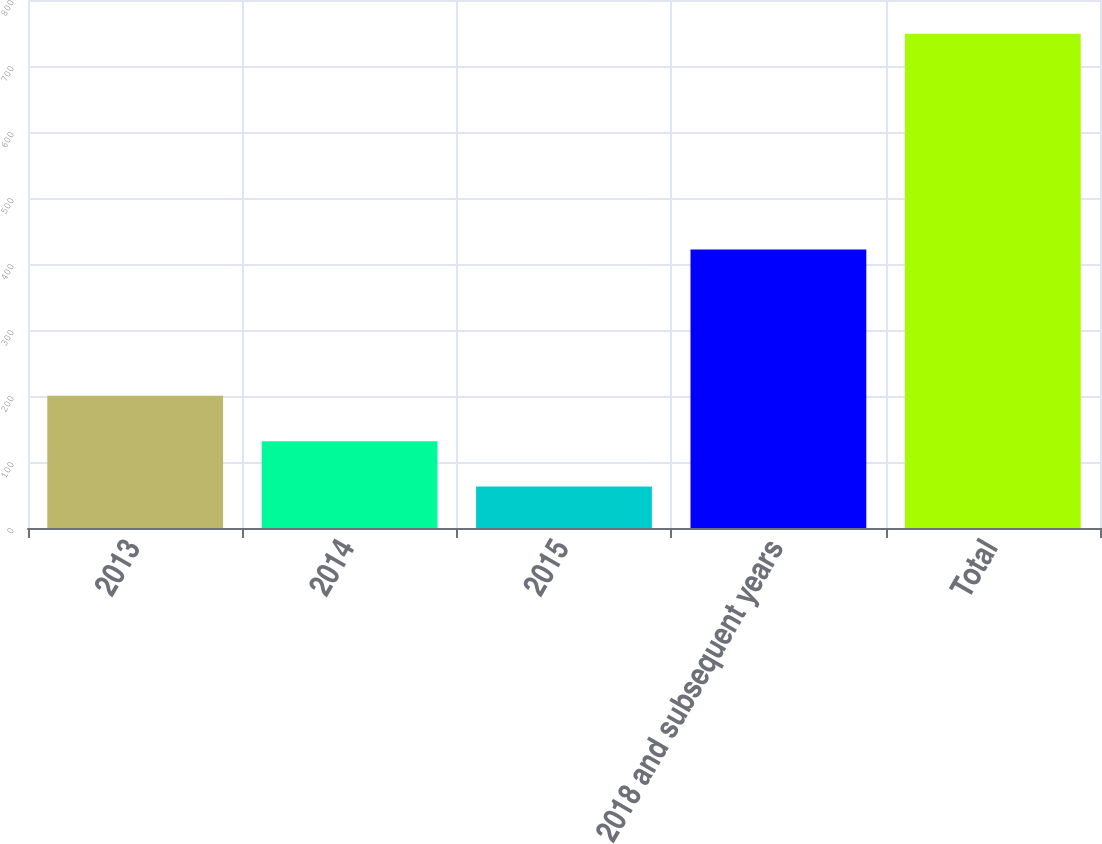Convert chart to OTSL. <chart><loc_0><loc_0><loc_500><loc_500><bar_chart><fcel>2013<fcel>2014<fcel>2015<fcel>2018 and subsequent years<fcel>Total<nl><fcel>200.2<fcel>131.6<fcel>63<fcel>422<fcel>749<nl></chart> 